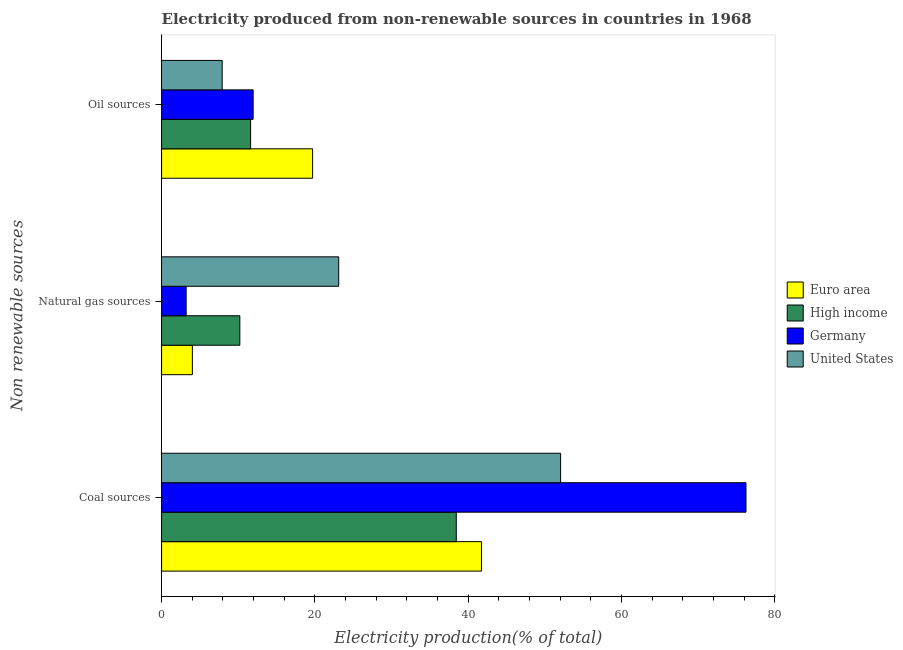How many groups of bars are there?
Your response must be concise. 3. Are the number of bars per tick equal to the number of legend labels?
Make the answer very short. Yes. Are the number of bars on each tick of the Y-axis equal?
Give a very brief answer. Yes. How many bars are there on the 1st tick from the top?
Make the answer very short. 4. How many bars are there on the 3rd tick from the bottom?
Offer a terse response. 4. What is the label of the 3rd group of bars from the top?
Ensure brevity in your answer.  Coal sources. What is the percentage of electricity produced by oil sources in Germany?
Your response must be concise. 11.95. Across all countries, what is the maximum percentage of electricity produced by coal?
Offer a terse response. 76.25. Across all countries, what is the minimum percentage of electricity produced by coal?
Your response must be concise. 38.45. What is the total percentage of electricity produced by natural gas in the graph?
Your response must be concise. 40.54. What is the difference between the percentage of electricity produced by natural gas in Euro area and that in High income?
Offer a terse response. -6.19. What is the difference between the percentage of electricity produced by natural gas in United States and the percentage of electricity produced by coal in High income?
Ensure brevity in your answer.  -15.34. What is the average percentage of electricity produced by coal per country?
Your answer should be compact. 52.12. What is the difference between the percentage of electricity produced by oil sources and percentage of electricity produced by natural gas in High income?
Offer a terse response. 1.4. What is the ratio of the percentage of electricity produced by oil sources in High income to that in Euro area?
Your response must be concise. 0.59. What is the difference between the highest and the second highest percentage of electricity produced by oil sources?
Your answer should be compact. 7.76. What is the difference between the highest and the lowest percentage of electricity produced by coal?
Provide a succinct answer. 37.8. Is the sum of the percentage of electricity produced by natural gas in United States and Euro area greater than the maximum percentage of electricity produced by coal across all countries?
Make the answer very short. No. Is it the case that in every country, the sum of the percentage of electricity produced by coal and percentage of electricity produced by natural gas is greater than the percentage of electricity produced by oil sources?
Provide a succinct answer. Yes. How many countries are there in the graph?
Offer a terse response. 4. What is the difference between two consecutive major ticks on the X-axis?
Offer a terse response. 20. Does the graph contain grids?
Ensure brevity in your answer.  No. Where does the legend appear in the graph?
Your response must be concise. Center right. What is the title of the graph?
Your response must be concise. Electricity produced from non-renewable sources in countries in 1968. What is the label or title of the X-axis?
Offer a terse response. Electricity production(% of total). What is the label or title of the Y-axis?
Provide a succinct answer. Non renewable sources. What is the Electricity production(% of total) of Euro area in Coal sources?
Provide a short and direct response. 41.74. What is the Electricity production(% of total) of High income in Coal sources?
Your response must be concise. 38.45. What is the Electricity production(% of total) of Germany in Coal sources?
Provide a short and direct response. 76.25. What is the Electricity production(% of total) of United States in Coal sources?
Provide a short and direct response. 52.06. What is the Electricity production(% of total) of Euro area in Natural gas sources?
Give a very brief answer. 4.02. What is the Electricity production(% of total) in High income in Natural gas sources?
Give a very brief answer. 10.21. What is the Electricity production(% of total) of Germany in Natural gas sources?
Your response must be concise. 3.21. What is the Electricity production(% of total) in United States in Natural gas sources?
Offer a terse response. 23.11. What is the Electricity production(% of total) in Euro area in Oil sources?
Your response must be concise. 19.7. What is the Electricity production(% of total) in High income in Oil sources?
Give a very brief answer. 11.61. What is the Electricity production(% of total) of Germany in Oil sources?
Provide a short and direct response. 11.95. What is the Electricity production(% of total) of United States in Oil sources?
Your answer should be compact. 7.91. Across all Non renewable sources, what is the maximum Electricity production(% of total) of Euro area?
Make the answer very short. 41.74. Across all Non renewable sources, what is the maximum Electricity production(% of total) in High income?
Give a very brief answer. 38.45. Across all Non renewable sources, what is the maximum Electricity production(% of total) in Germany?
Provide a short and direct response. 76.25. Across all Non renewable sources, what is the maximum Electricity production(% of total) of United States?
Make the answer very short. 52.06. Across all Non renewable sources, what is the minimum Electricity production(% of total) in Euro area?
Your answer should be very brief. 4.02. Across all Non renewable sources, what is the minimum Electricity production(% of total) in High income?
Keep it short and to the point. 10.21. Across all Non renewable sources, what is the minimum Electricity production(% of total) of Germany?
Offer a terse response. 3.21. Across all Non renewable sources, what is the minimum Electricity production(% of total) in United States?
Offer a very short reply. 7.91. What is the total Electricity production(% of total) in Euro area in the graph?
Provide a short and direct response. 65.46. What is the total Electricity production(% of total) in High income in the graph?
Ensure brevity in your answer.  60.27. What is the total Electricity production(% of total) of Germany in the graph?
Provide a succinct answer. 91.4. What is the total Electricity production(% of total) of United States in the graph?
Provide a succinct answer. 83.07. What is the difference between the Electricity production(% of total) of Euro area in Coal sources and that in Natural gas sources?
Your answer should be compact. 37.72. What is the difference between the Electricity production(% of total) of High income in Coal sources and that in Natural gas sources?
Your response must be concise. 28.24. What is the difference between the Electricity production(% of total) of Germany in Coal sources and that in Natural gas sources?
Provide a succinct answer. 73.04. What is the difference between the Electricity production(% of total) of United States in Coal sources and that in Natural gas sources?
Provide a succinct answer. 28.95. What is the difference between the Electricity production(% of total) in Euro area in Coal sources and that in Oil sources?
Provide a succinct answer. 22.03. What is the difference between the Electricity production(% of total) in High income in Coal sources and that in Oil sources?
Provide a succinct answer. 26.84. What is the difference between the Electricity production(% of total) in Germany in Coal sources and that in Oil sources?
Offer a very short reply. 64.3. What is the difference between the Electricity production(% of total) of United States in Coal sources and that in Oil sources?
Provide a succinct answer. 44.15. What is the difference between the Electricity production(% of total) of Euro area in Natural gas sources and that in Oil sources?
Provide a succinct answer. -15.69. What is the difference between the Electricity production(% of total) in High income in Natural gas sources and that in Oil sources?
Offer a terse response. -1.4. What is the difference between the Electricity production(% of total) of Germany in Natural gas sources and that in Oil sources?
Your answer should be compact. -8.74. What is the difference between the Electricity production(% of total) in United States in Natural gas sources and that in Oil sources?
Make the answer very short. 15.2. What is the difference between the Electricity production(% of total) in Euro area in Coal sources and the Electricity production(% of total) in High income in Natural gas sources?
Your answer should be very brief. 31.53. What is the difference between the Electricity production(% of total) of Euro area in Coal sources and the Electricity production(% of total) of Germany in Natural gas sources?
Keep it short and to the point. 38.53. What is the difference between the Electricity production(% of total) of Euro area in Coal sources and the Electricity production(% of total) of United States in Natural gas sources?
Your response must be concise. 18.63. What is the difference between the Electricity production(% of total) of High income in Coal sources and the Electricity production(% of total) of Germany in Natural gas sources?
Offer a terse response. 35.24. What is the difference between the Electricity production(% of total) in High income in Coal sources and the Electricity production(% of total) in United States in Natural gas sources?
Offer a very short reply. 15.34. What is the difference between the Electricity production(% of total) in Germany in Coal sources and the Electricity production(% of total) in United States in Natural gas sources?
Make the answer very short. 53.14. What is the difference between the Electricity production(% of total) in Euro area in Coal sources and the Electricity production(% of total) in High income in Oil sources?
Ensure brevity in your answer.  30.13. What is the difference between the Electricity production(% of total) in Euro area in Coal sources and the Electricity production(% of total) in Germany in Oil sources?
Your answer should be compact. 29.79. What is the difference between the Electricity production(% of total) in Euro area in Coal sources and the Electricity production(% of total) in United States in Oil sources?
Ensure brevity in your answer.  33.83. What is the difference between the Electricity production(% of total) of High income in Coal sources and the Electricity production(% of total) of Germany in Oil sources?
Provide a succinct answer. 26.5. What is the difference between the Electricity production(% of total) of High income in Coal sources and the Electricity production(% of total) of United States in Oil sources?
Your answer should be compact. 30.54. What is the difference between the Electricity production(% of total) in Germany in Coal sources and the Electricity production(% of total) in United States in Oil sources?
Offer a very short reply. 68.34. What is the difference between the Electricity production(% of total) of Euro area in Natural gas sources and the Electricity production(% of total) of High income in Oil sources?
Provide a short and direct response. -7.59. What is the difference between the Electricity production(% of total) in Euro area in Natural gas sources and the Electricity production(% of total) in Germany in Oil sources?
Offer a very short reply. -7.93. What is the difference between the Electricity production(% of total) of Euro area in Natural gas sources and the Electricity production(% of total) of United States in Oil sources?
Your answer should be compact. -3.89. What is the difference between the Electricity production(% of total) of High income in Natural gas sources and the Electricity production(% of total) of Germany in Oil sources?
Provide a short and direct response. -1.74. What is the difference between the Electricity production(% of total) in High income in Natural gas sources and the Electricity production(% of total) in United States in Oil sources?
Your answer should be very brief. 2.3. What is the difference between the Electricity production(% of total) of Germany in Natural gas sources and the Electricity production(% of total) of United States in Oil sources?
Make the answer very short. -4.7. What is the average Electricity production(% of total) in Euro area per Non renewable sources?
Offer a very short reply. 21.82. What is the average Electricity production(% of total) in High income per Non renewable sources?
Keep it short and to the point. 20.09. What is the average Electricity production(% of total) in Germany per Non renewable sources?
Ensure brevity in your answer.  30.47. What is the average Electricity production(% of total) of United States per Non renewable sources?
Your answer should be very brief. 27.69. What is the difference between the Electricity production(% of total) in Euro area and Electricity production(% of total) in High income in Coal sources?
Offer a very short reply. 3.29. What is the difference between the Electricity production(% of total) in Euro area and Electricity production(% of total) in Germany in Coal sources?
Provide a short and direct response. -34.51. What is the difference between the Electricity production(% of total) of Euro area and Electricity production(% of total) of United States in Coal sources?
Offer a terse response. -10.32. What is the difference between the Electricity production(% of total) in High income and Electricity production(% of total) in Germany in Coal sources?
Your answer should be very brief. -37.8. What is the difference between the Electricity production(% of total) in High income and Electricity production(% of total) in United States in Coal sources?
Your answer should be very brief. -13.61. What is the difference between the Electricity production(% of total) of Germany and Electricity production(% of total) of United States in Coal sources?
Your answer should be very brief. 24.19. What is the difference between the Electricity production(% of total) in Euro area and Electricity production(% of total) in High income in Natural gas sources?
Provide a short and direct response. -6.19. What is the difference between the Electricity production(% of total) of Euro area and Electricity production(% of total) of Germany in Natural gas sources?
Offer a very short reply. 0.81. What is the difference between the Electricity production(% of total) in Euro area and Electricity production(% of total) in United States in Natural gas sources?
Offer a terse response. -19.09. What is the difference between the Electricity production(% of total) in High income and Electricity production(% of total) in Germany in Natural gas sources?
Provide a succinct answer. 7. What is the difference between the Electricity production(% of total) of High income and Electricity production(% of total) of United States in Natural gas sources?
Provide a short and direct response. -12.9. What is the difference between the Electricity production(% of total) in Germany and Electricity production(% of total) in United States in Natural gas sources?
Ensure brevity in your answer.  -19.9. What is the difference between the Electricity production(% of total) of Euro area and Electricity production(% of total) of High income in Oil sources?
Provide a succinct answer. 8.09. What is the difference between the Electricity production(% of total) in Euro area and Electricity production(% of total) in Germany in Oil sources?
Ensure brevity in your answer.  7.76. What is the difference between the Electricity production(% of total) of Euro area and Electricity production(% of total) of United States in Oil sources?
Your answer should be very brief. 11.8. What is the difference between the Electricity production(% of total) of High income and Electricity production(% of total) of Germany in Oil sources?
Your answer should be very brief. -0.33. What is the difference between the Electricity production(% of total) in High income and Electricity production(% of total) in United States in Oil sources?
Your answer should be compact. 3.71. What is the difference between the Electricity production(% of total) of Germany and Electricity production(% of total) of United States in Oil sources?
Your response must be concise. 4.04. What is the ratio of the Electricity production(% of total) of Euro area in Coal sources to that in Natural gas sources?
Your response must be concise. 10.39. What is the ratio of the Electricity production(% of total) in High income in Coal sources to that in Natural gas sources?
Provide a short and direct response. 3.77. What is the ratio of the Electricity production(% of total) of Germany in Coal sources to that in Natural gas sources?
Your answer should be very brief. 23.77. What is the ratio of the Electricity production(% of total) of United States in Coal sources to that in Natural gas sources?
Your answer should be very brief. 2.25. What is the ratio of the Electricity production(% of total) in Euro area in Coal sources to that in Oil sources?
Provide a succinct answer. 2.12. What is the ratio of the Electricity production(% of total) of High income in Coal sources to that in Oil sources?
Your response must be concise. 3.31. What is the ratio of the Electricity production(% of total) in Germany in Coal sources to that in Oil sources?
Your answer should be very brief. 6.38. What is the ratio of the Electricity production(% of total) of United States in Coal sources to that in Oil sources?
Give a very brief answer. 6.59. What is the ratio of the Electricity production(% of total) of Euro area in Natural gas sources to that in Oil sources?
Keep it short and to the point. 0.2. What is the ratio of the Electricity production(% of total) in High income in Natural gas sources to that in Oil sources?
Provide a succinct answer. 0.88. What is the ratio of the Electricity production(% of total) in Germany in Natural gas sources to that in Oil sources?
Ensure brevity in your answer.  0.27. What is the ratio of the Electricity production(% of total) in United States in Natural gas sources to that in Oil sources?
Ensure brevity in your answer.  2.92. What is the difference between the highest and the second highest Electricity production(% of total) in Euro area?
Offer a very short reply. 22.03. What is the difference between the highest and the second highest Electricity production(% of total) in High income?
Provide a succinct answer. 26.84. What is the difference between the highest and the second highest Electricity production(% of total) of Germany?
Keep it short and to the point. 64.3. What is the difference between the highest and the second highest Electricity production(% of total) in United States?
Keep it short and to the point. 28.95. What is the difference between the highest and the lowest Electricity production(% of total) in Euro area?
Provide a short and direct response. 37.72. What is the difference between the highest and the lowest Electricity production(% of total) in High income?
Offer a terse response. 28.24. What is the difference between the highest and the lowest Electricity production(% of total) in Germany?
Offer a very short reply. 73.04. What is the difference between the highest and the lowest Electricity production(% of total) of United States?
Ensure brevity in your answer.  44.15. 